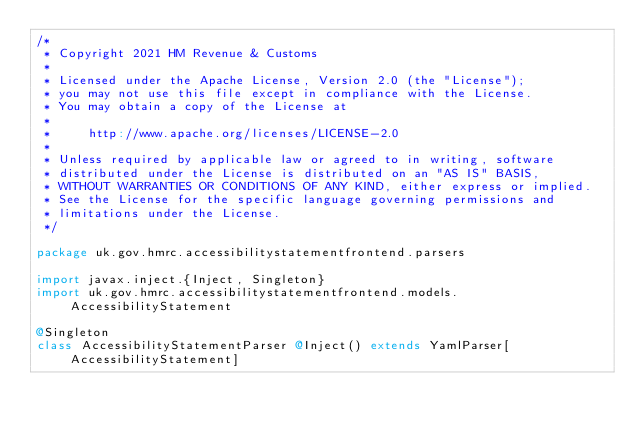Convert code to text. <code><loc_0><loc_0><loc_500><loc_500><_Scala_>/*
 * Copyright 2021 HM Revenue & Customs
 *
 * Licensed under the Apache License, Version 2.0 (the "License");
 * you may not use this file except in compliance with the License.
 * You may obtain a copy of the License at
 *
 *     http://www.apache.org/licenses/LICENSE-2.0
 *
 * Unless required by applicable law or agreed to in writing, software
 * distributed under the License is distributed on an "AS IS" BASIS,
 * WITHOUT WARRANTIES OR CONDITIONS OF ANY KIND, either express or implied.
 * See the License for the specific language governing permissions and
 * limitations under the License.
 */

package uk.gov.hmrc.accessibilitystatementfrontend.parsers

import javax.inject.{Inject, Singleton}
import uk.gov.hmrc.accessibilitystatementfrontend.models.AccessibilityStatement

@Singleton
class AccessibilityStatementParser @Inject() extends YamlParser[AccessibilityStatement]
</code> 